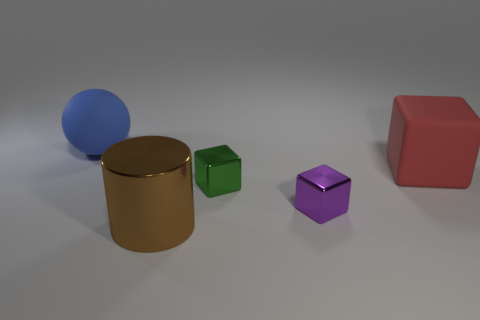Subtract all tiny metallic cubes. How many cubes are left? 1 Subtract 1 cubes. How many cubes are left? 2 Add 1 purple shiny cubes. How many objects exist? 6 Subtract all spheres. How many objects are left? 4 Subtract all big cubes. Subtract all tiny blocks. How many objects are left? 2 Add 5 brown cylinders. How many brown cylinders are left? 6 Add 4 green blocks. How many green blocks exist? 5 Subtract 0 red balls. How many objects are left? 5 